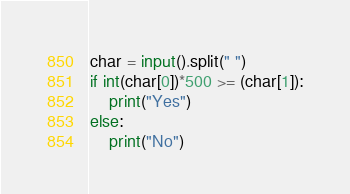Convert code to text. <code><loc_0><loc_0><loc_500><loc_500><_Python_>char = input().split(" ")
if int(char[0])*500 >= (char[1]):
    print("Yes")
else: 
    print("No")</code> 